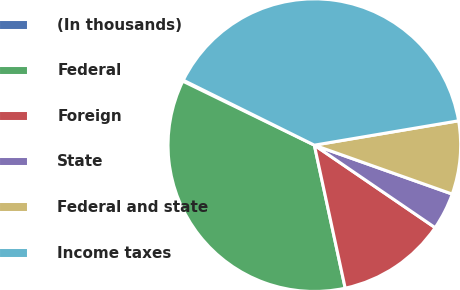Convert chart to OTSL. <chart><loc_0><loc_0><loc_500><loc_500><pie_chart><fcel>(In thousands)<fcel>Federal<fcel>Foreign<fcel>State<fcel>Federal and state<fcel>Income taxes<nl><fcel>0.12%<fcel>35.59%<fcel>12.08%<fcel>4.11%<fcel>8.09%<fcel>40.01%<nl></chart> 